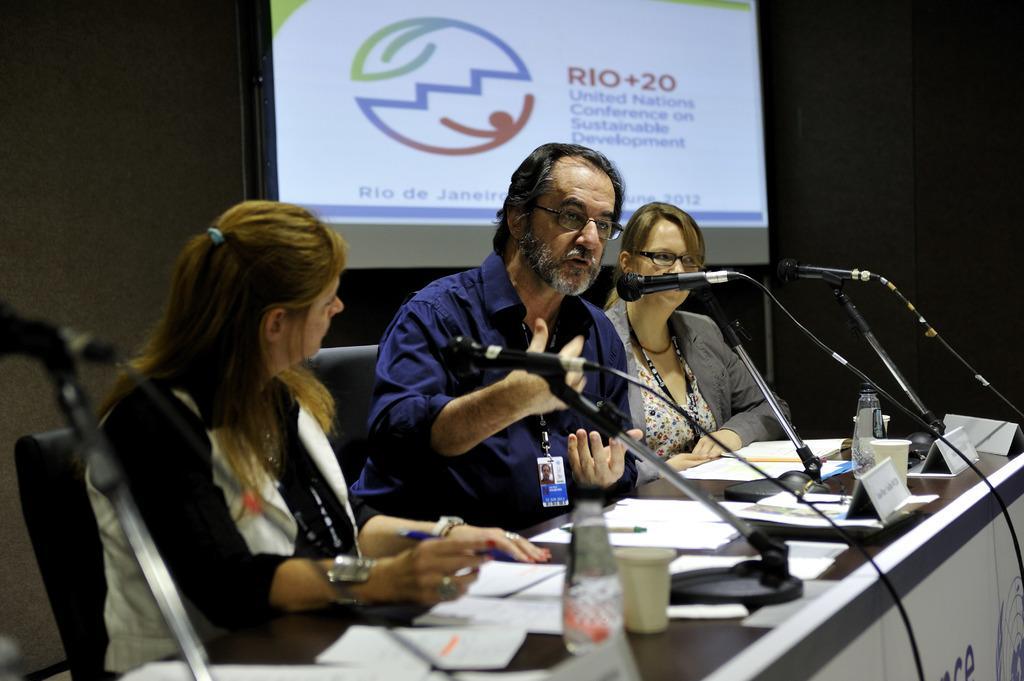Could you give a brief overview of what you see in this image? In this image I can see few people are sitting on chairs. In the front of them I can see a table and on it I can see number of papers, few bottles, few boards and few mics. In the background I can see a projector's screen and on it I can see something is written. 